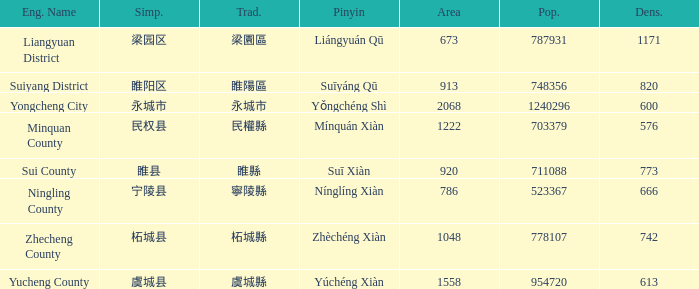How many areas have a population of 703379? 1.0. 